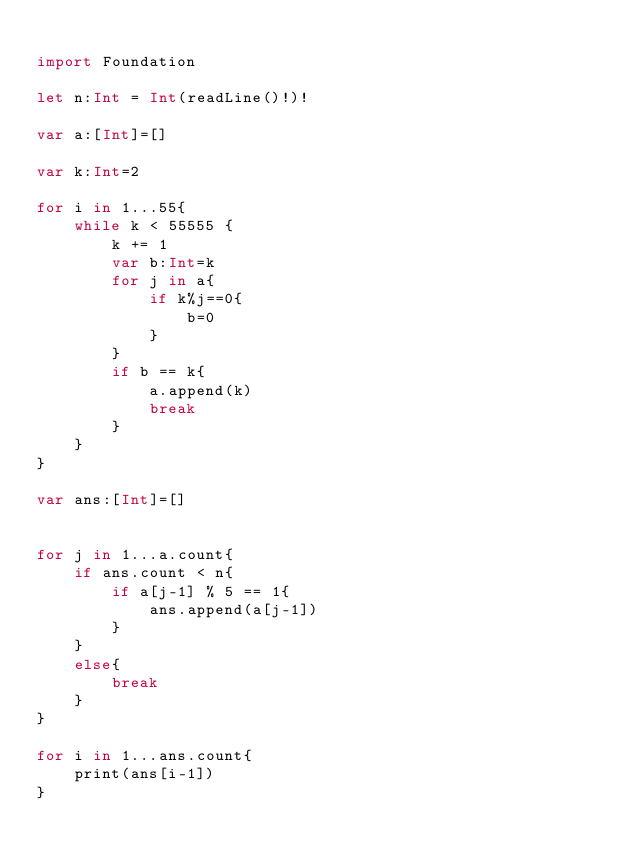<code> <loc_0><loc_0><loc_500><loc_500><_Swift_>
import Foundation

let n:Int = Int(readLine()!)!

var a:[Int]=[]

var k:Int=2

for i in 1...55{
    while k < 55555 {
        k += 1
        var b:Int=k
        for j in a{
            if k%j==0{
                b=0
            }
        }
        if b == k{
            a.append(k)
            break
        }
    }
}

var ans:[Int]=[]


for j in 1...a.count{
    if ans.count < n{
        if a[j-1] % 5 == 1{
            ans.append(a[j-1])
        }
    }
    else{
        break
    }
}
            
for i in 1...ans.count{
    print(ans[i-1])
}

              
</code> 